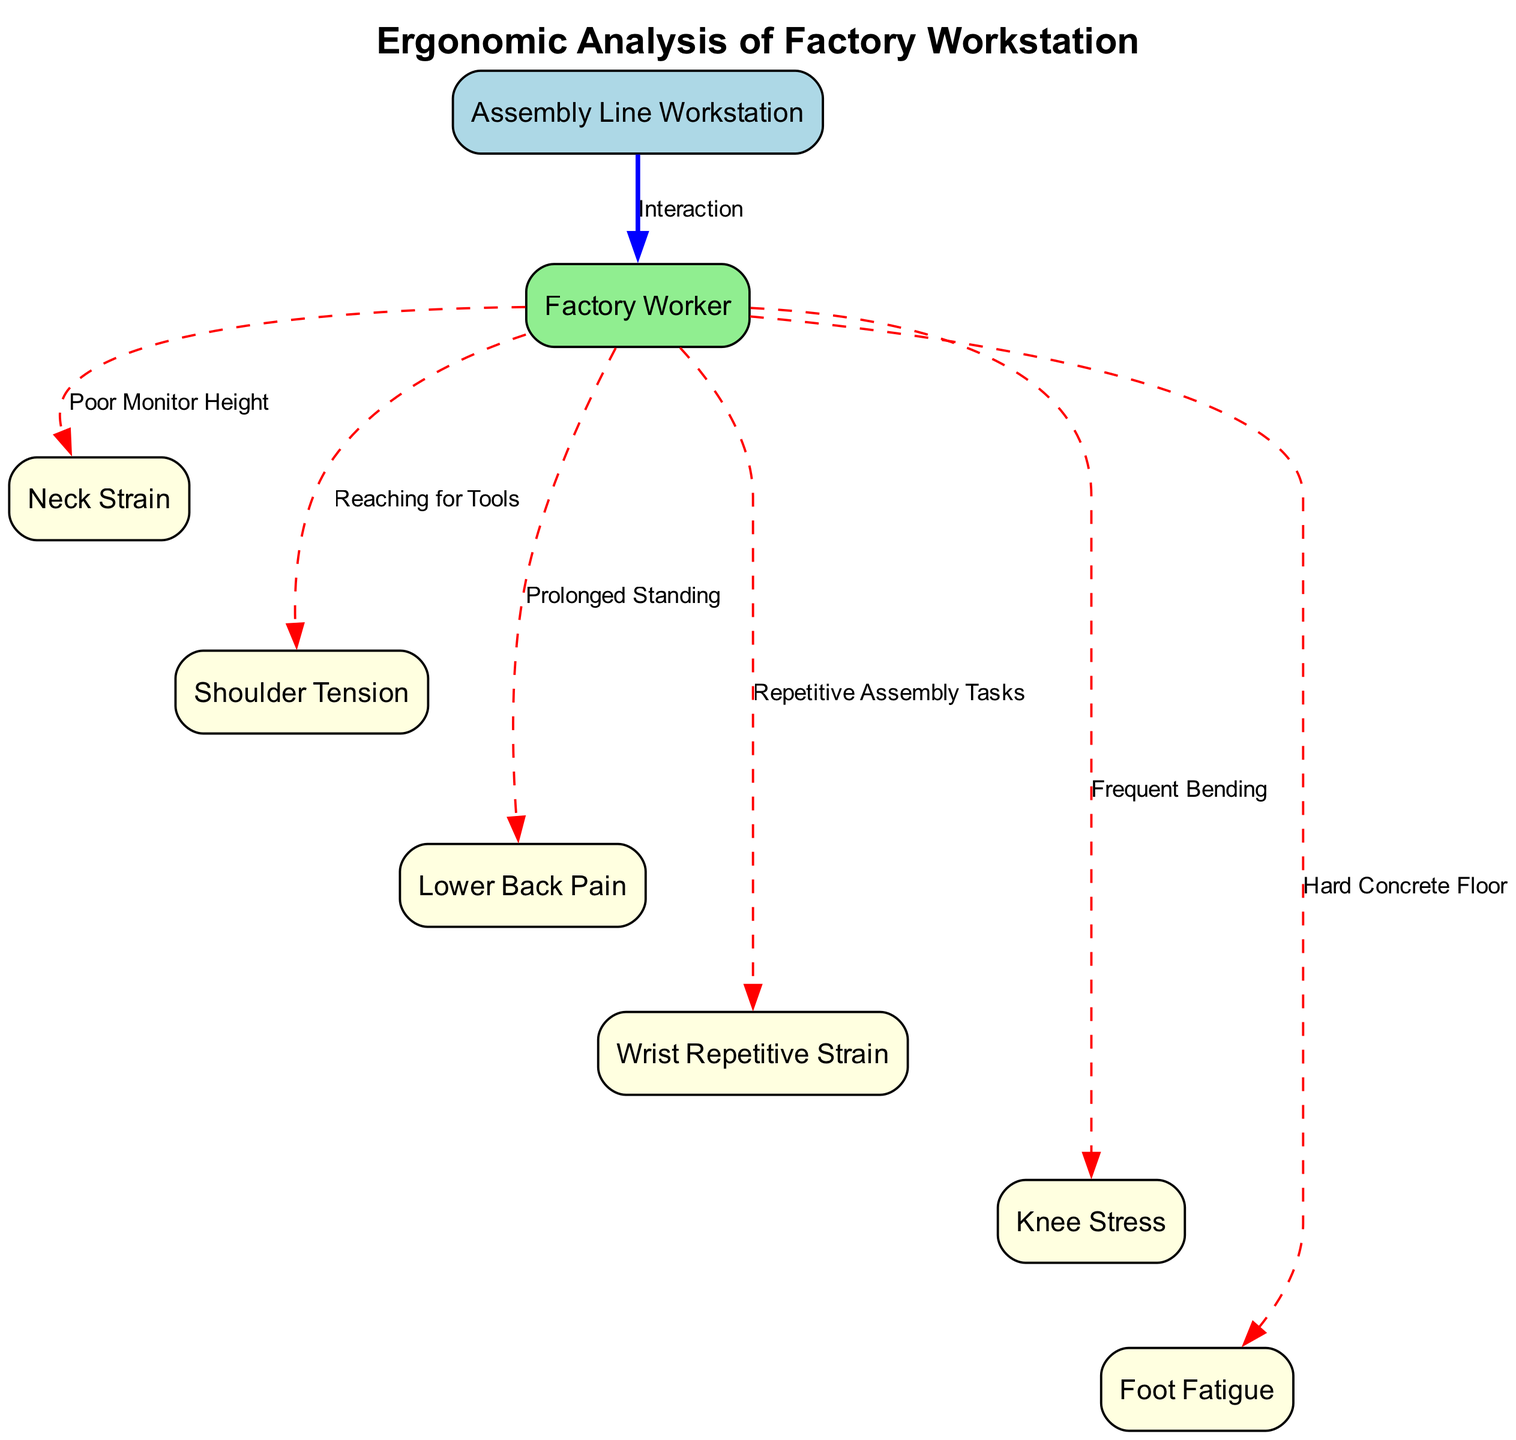What is the title of the diagram? The title of the diagram is presented at the top and indicates the main subject of the visual representation. That subject is "Ergonomic Analysis of Factory Workstation."
Answer: Ergonomic Analysis of Factory Workstation How many nodes are present in the diagram? By counting the nodes listed in the "nodes" section of the data, we see there are a total of 8 nodes representing different elements.
Answer: 8 What does the edge from "workstation" to "worker" represent? The edge labeled "Interaction" between the "workstation" and "worker" indicates a direct relationship. It signifies that the workstation affects or involves the worker.
Answer: Interaction Which body part is associated with "Poor Monitor Height"? The connection label "Poor Monitor Height" leads to the "neck" node, indicating that improper monitor height is a primary cause of neck strain.
Answer: Neck Strain What are the two body parts connected by the edge labeled "Reaching for Tools"? The edge labeled "Reaching for Tools" connects the "worker" to the "shoulders" node, indicating that reaching affects shoulder tension.
Answer: Shoulders How does "Prolonged Standing" affect a worker? The "Prolonged Standing" label leads from the "worker" to the "back," denoting that standing for an extended time can lead to lower back pain.
Answer: Lower Back Pain What type of floor is indicated as a source of "Foot Fatigue"? The "worker" node points to "feet" through the connecting label "Hard Concrete Floor." This suggests that a hard concrete floor can cause fatigue in the feet.
Answer: Hard Concrete Floor Which stress point is linked to "Frequent Bending"? The edge marked "Frequent Bending" connects the "worker" to the "knees," indicating that frequent bending can cause stress in the knee area.
Answer: Knee Stress 